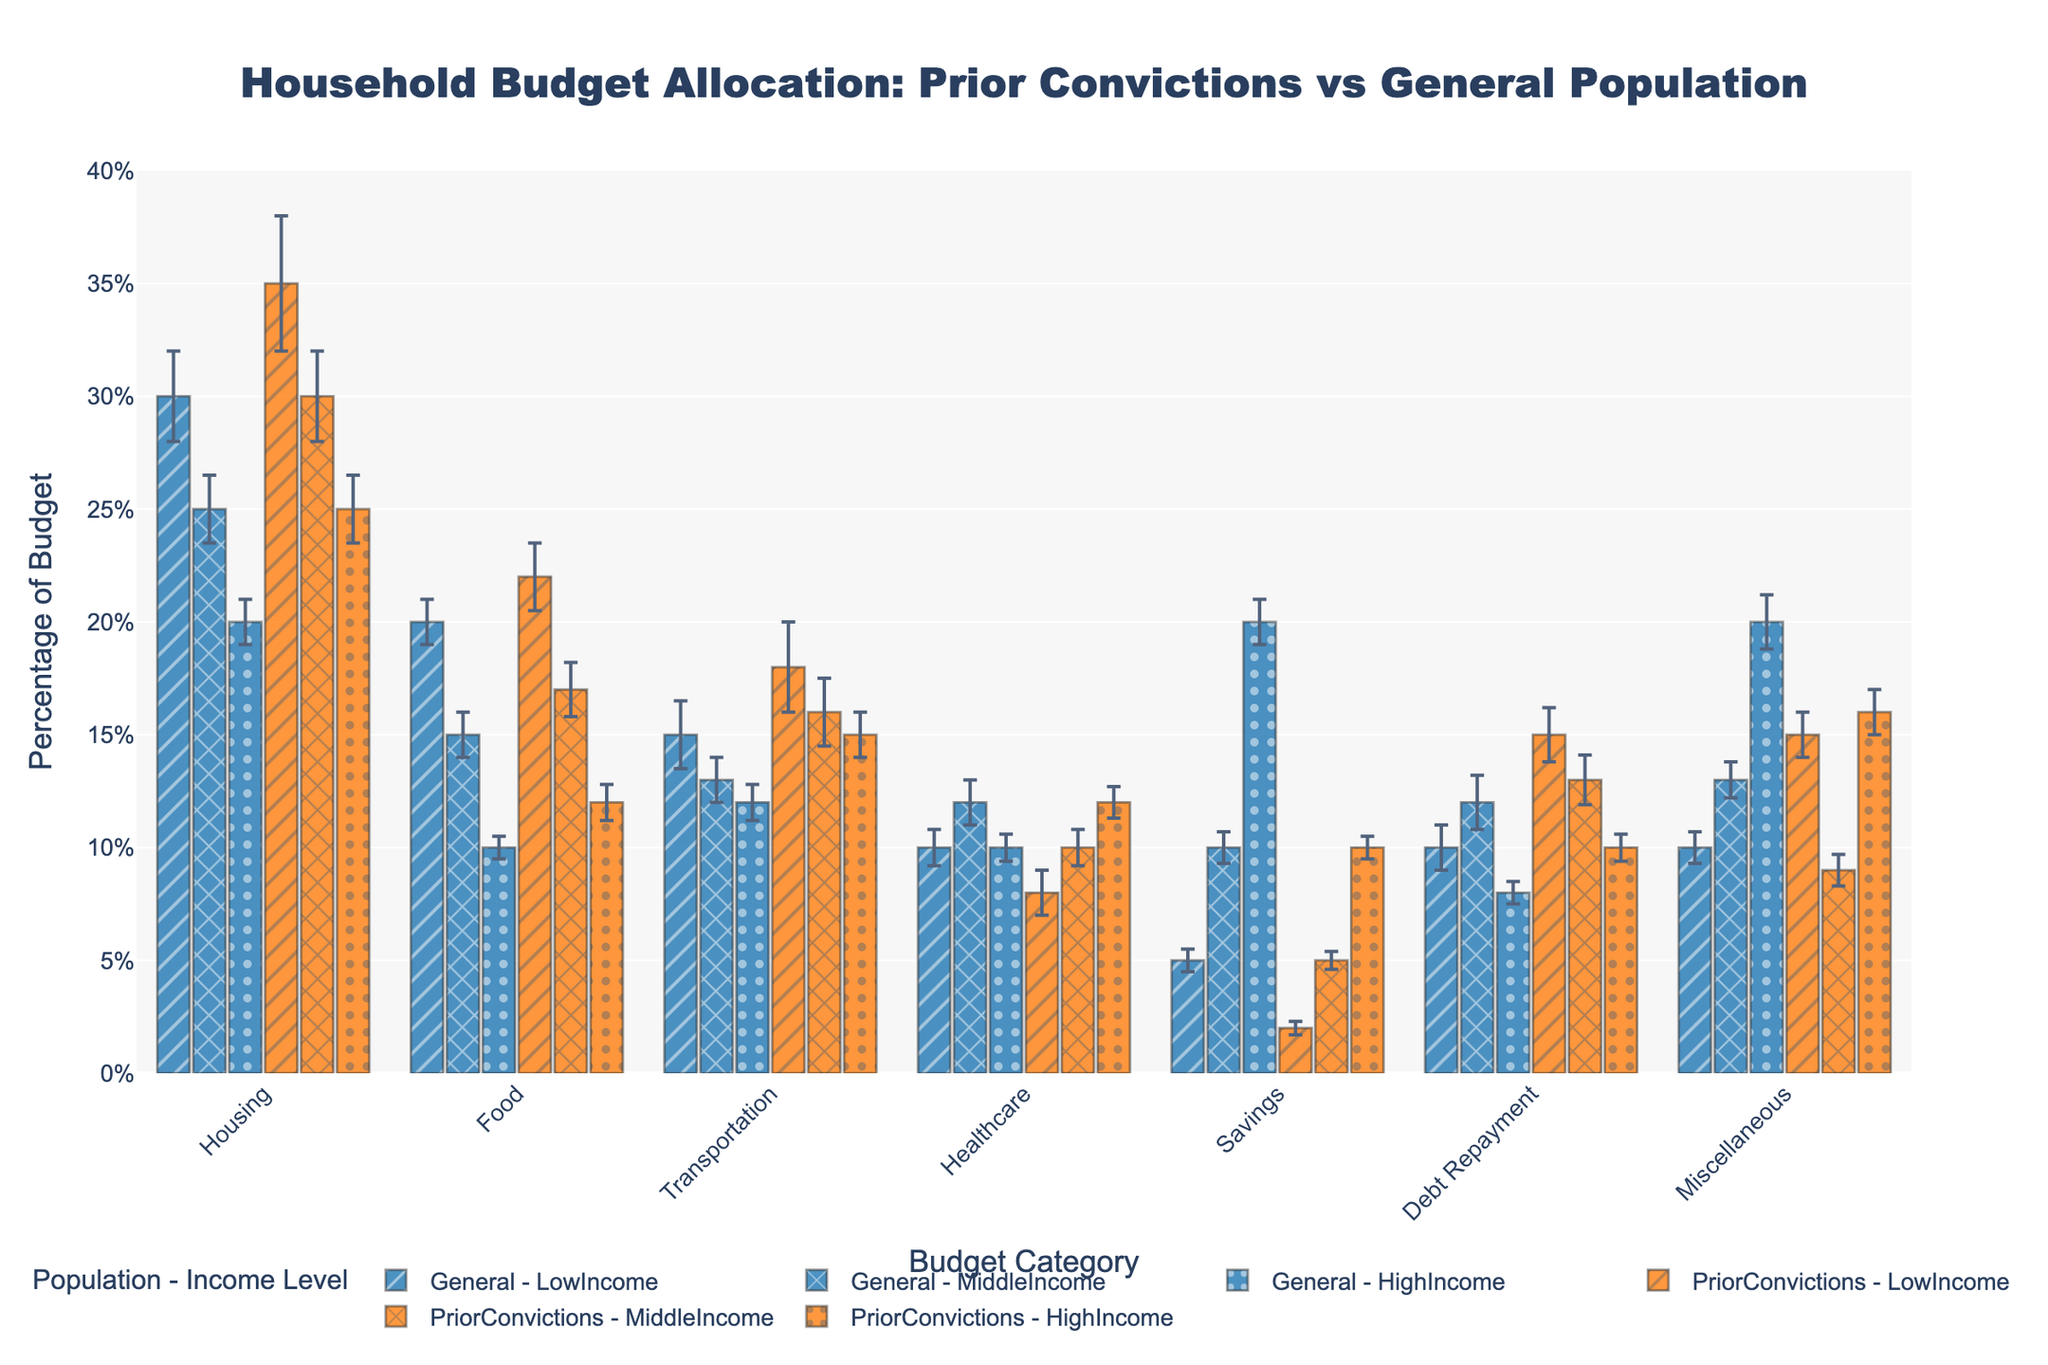What is the title of the bar chart? The title is displayed at the top of the figure and summarizes the main topic of the chart.
Answer: Household Budget Allocation: Prior Convictions vs General Population What is the percentage spent on housing for individuals with prior convictions and low income? This information is found on the bar corresponding to the housing category for individuals with prior convictions and low income.
Answer: 35% Which population group spends the most on food? By comparing the heights of the bars in the food category for each population group, the group with the tallest bar represents the highest spending. For the rows marked food, the bar representing Prior Convictions - LowIncome is the highest.
Answer: Prior Convictions - LowIncome Compare the savings for individuals with high income between the general population and those with prior convictions. Observing the savings bars for high-income individuals in both populations, note their heights and compare the values. The bar heights for savings are 20% for general population and 10% for prior convictions.
Answer: The general population has double the savings of individuals with prior convictions (20% vs 10%) What is the percentage error for healthcare budget allocation in the middle income group for individuals with prior convictions? The percentage error is represented by the error bars. Check the error bar for the healthcare category under the middle-income group for individuals with prior convictions.
Answer: 0.8% Does the general population spend more or less on debt repayment compared to those with prior convictions in the middle-income group? Compare the heights of the debt repayment bars for the middle-income group between the general population and individuals with prior convictions. The bars show 12% for the general population and 13% for individuals with prior convictions.
Answer: Less (12% vs 13%) How does the spending on transportation differ between the general population and individuals with prior convictions for a high-income group? Compare the heights of the transportation bars for high-income earners in both populations. The bar heights are 12% for the general population and 15% for individuals with prior convictions.
Answer: 3% higher for individuals with prior convictions (15% vs 12%) Which category sees the highest allocation of the budget for low-income individuals with prior convictions? Examine the bar heights for all budget categories under Prior Convictions - LowIncome. The highest bar represents the largest budget allocation. The highest bar is for Housing at 35%.
Answer: Housing What is the difference in percentage spent on miscellaneous items between low-income individuals with prior convictions and the general population? Measure the difference between the bar heights for miscellaneous items between the two groups. The values are 15% for individuals with prior convictions and 10% for the general population, making the difference 5%.
Answer: 5% For middle-income individuals, which category has the smallest difference in budget allocation between the general population and those with prior convictions? Compare the bars for each category under the middle-income group and identify the smallest difference. The smallest difference in percentage can be seen under healthcare where both populations allocate the same percentage (10%).
Answer: Healthcare 